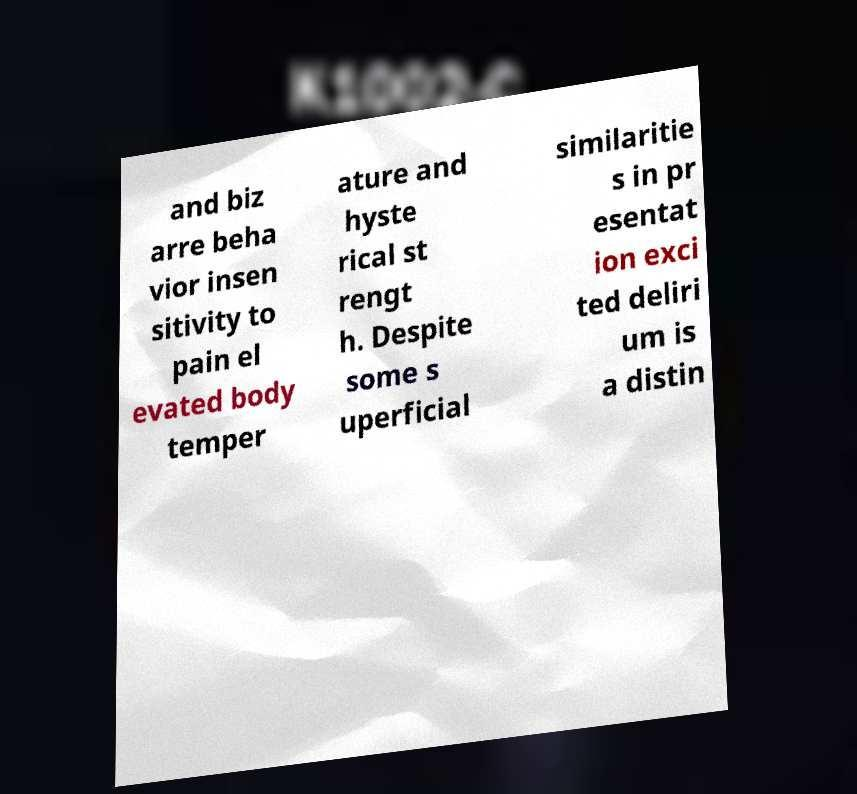Please read and relay the text visible in this image. What does it say? and biz arre beha vior insen sitivity to pain el evated body temper ature and hyste rical st rengt h. Despite some s uperficial similaritie s in pr esentat ion exci ted deliri um is a distin 